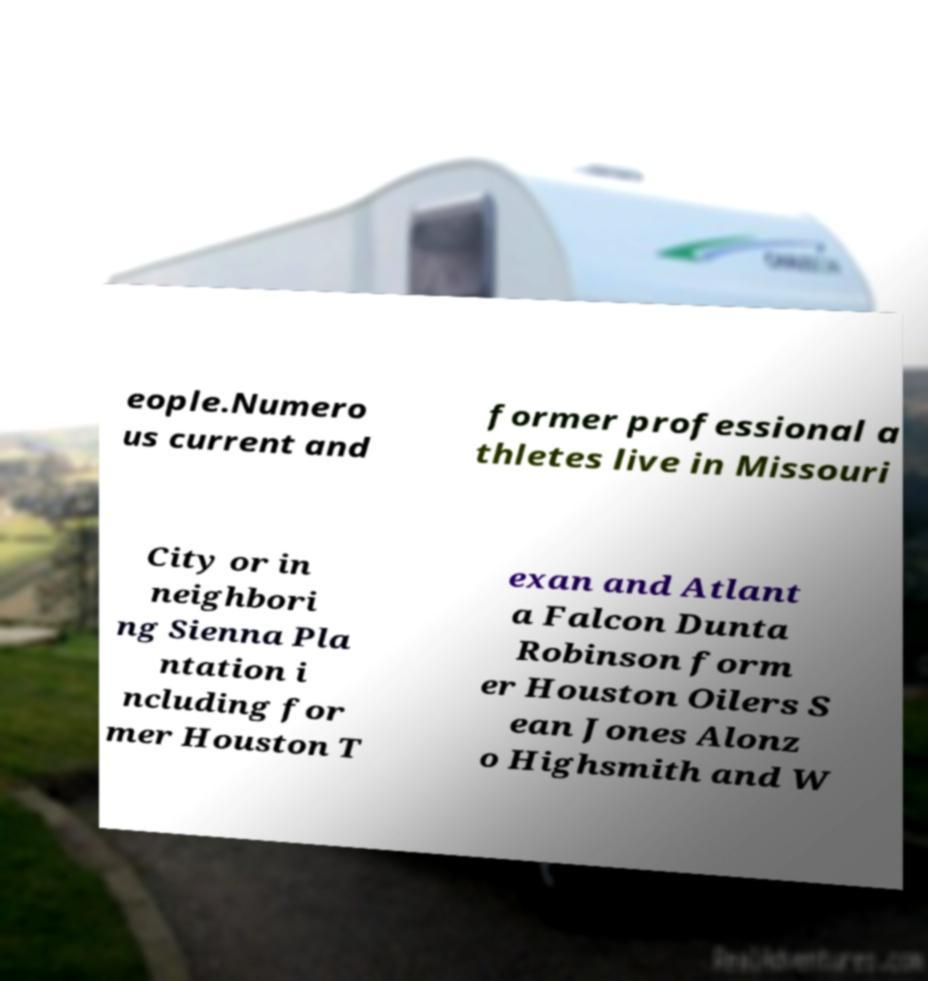Could you assist in decoding the text presented in this image and type it out clearly? eople.Numero us current and former professional a thletes live in Missouri City or in neighbori ng Sienna Pla ntation i ncluding for mer Houston T exan and Atlant a Falcon Dunta Robinson form er Houston Oilers S ean Jones Alonz o Highsmith and W 